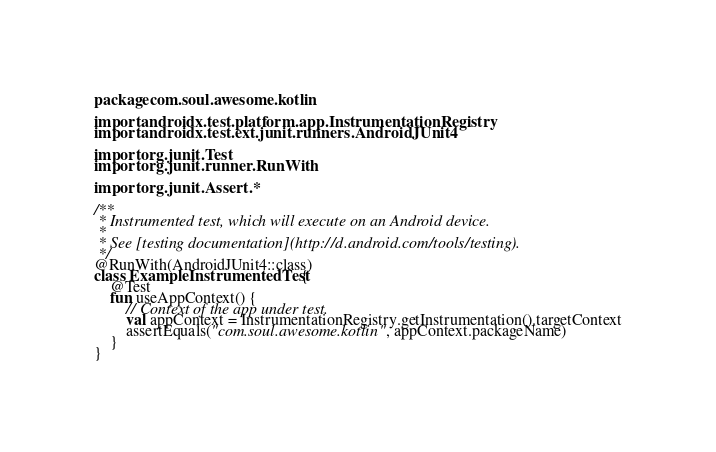Convert code to text. <code><loc_0><loc_0><loc_500><loc_500><_Kotlin_>package com.soul.awesome.kotlin

import androidx.test.platform.app.InstrumentationRegistry
import androidx.test.ext.junit.runners.AndroidJUnit4

import org.junit.Test
import org.junit.runner.RunWith

import org.junit.Assert.*

/**
 * Instrumented test, which will execute on an Android device.
 *
 * See [testing documentation](http://d.android.com/tools/testing).
 */
@RunWith(AndroidJUnit4::class)
class ExampleInstrumentedTest {
    @Test
    fun useAppContext() {
        // Context of the app under test.
        val appContext = InstrumentationRegistry.getInstrumentation().targetContext
        assertEquals("com.soul.awesome.kotlin", appContext.packageName)
    }
}</code> 